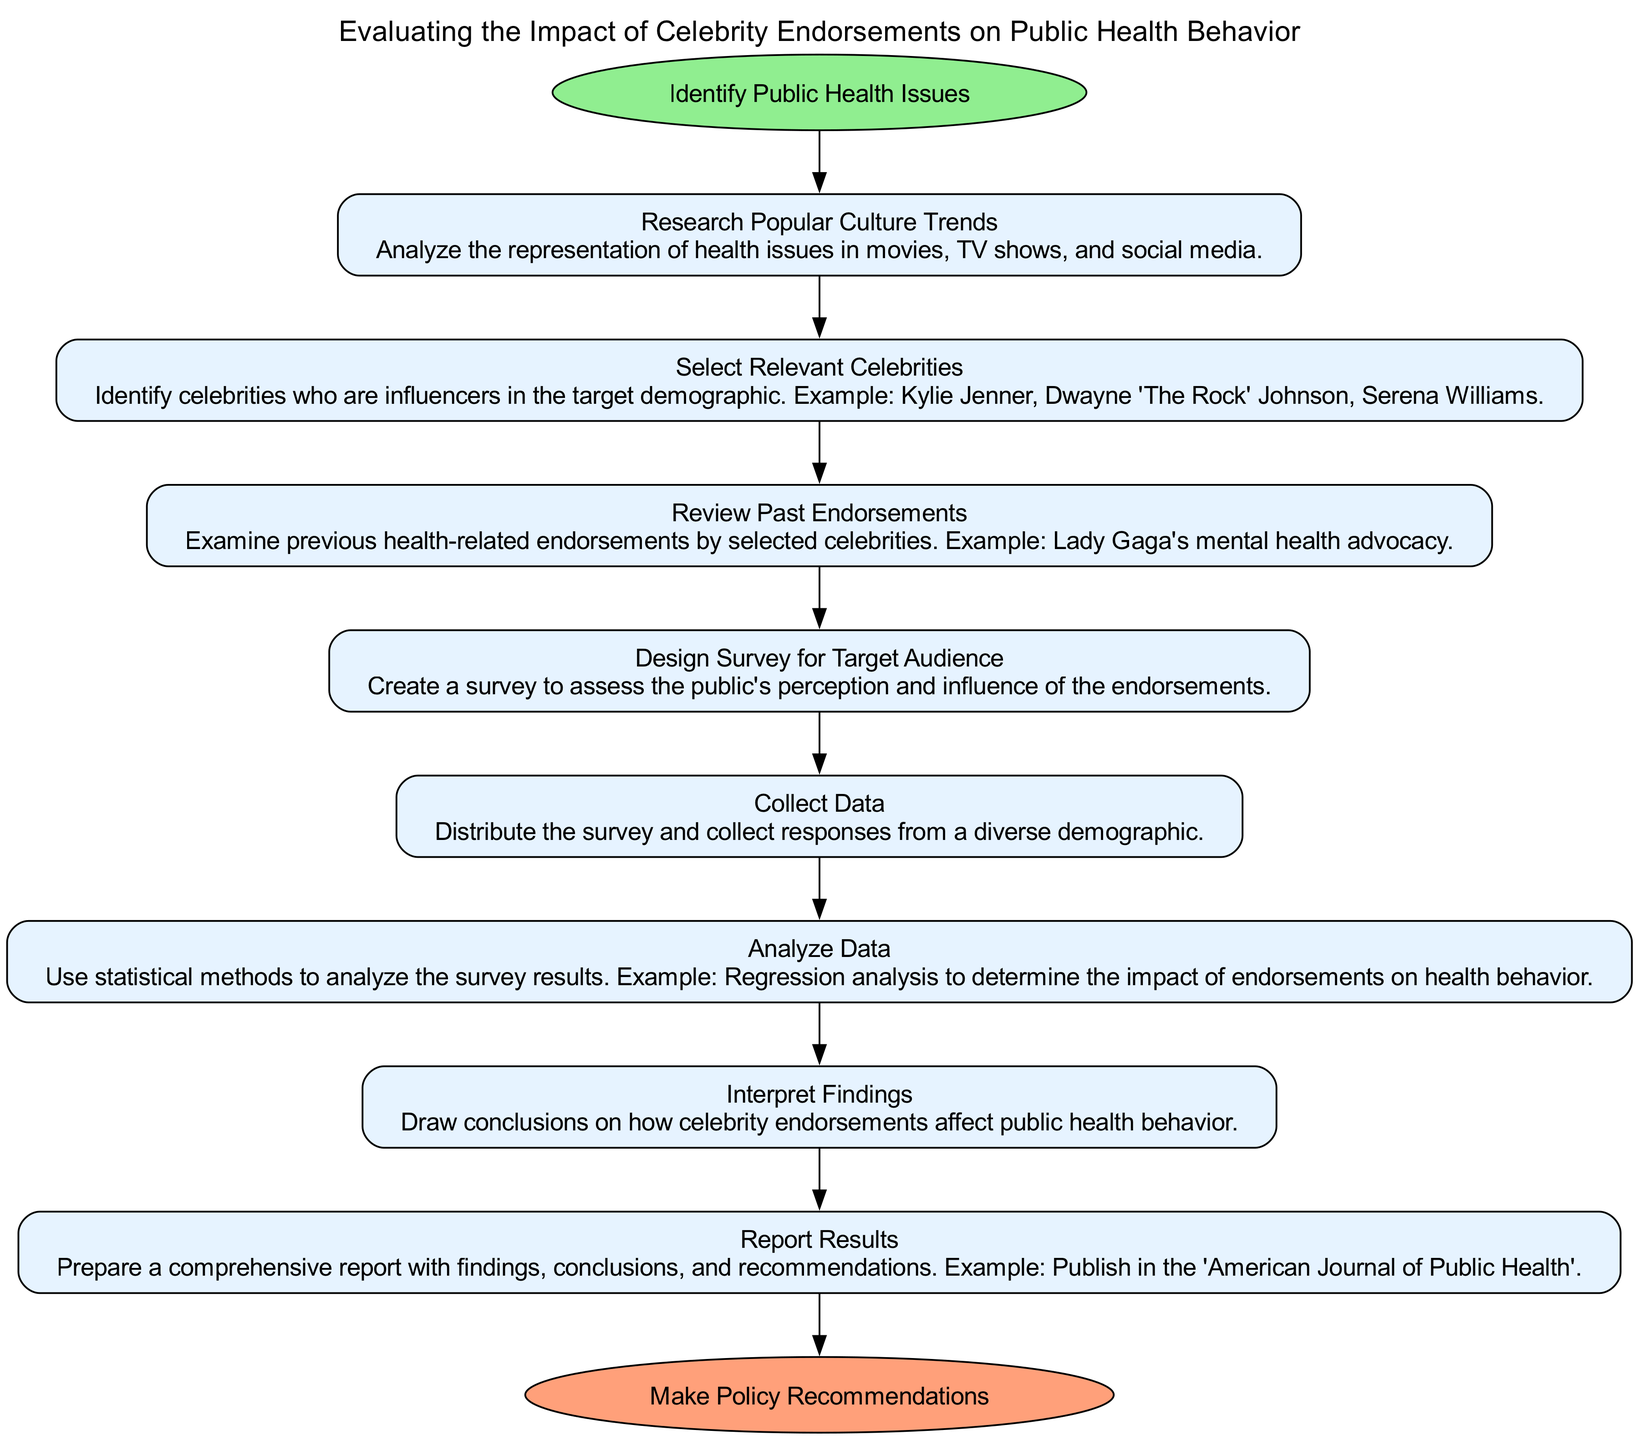What is the starting point of the evaluation process? The starting point is explicitly stated as "Identify Public Health Issues" in the diagram as the first node connected to the starting oval.
Answer: Identify Public Health Issues How many steps are involved in the evaluation process? By counting the number of nodes listed under the steps section in the diagram, there are eight distinct steps depicted.
Answer: Eight What is the last step before making policy recommendations? The last step listed is "Report Results," which directly precedes the endpoint in the flowchart's sequence of actions.
Answer: Report Results Which step follows "Review Past Endorsements"? According to the flow of the diagram, the step that immediately follows "Review Past Endorsements" is "Design Survey for Target Audience." This is connected by a directional edge.
Answer: Design Survey for Target Audience Which celebrities are mentioned as relevant influencers in the endorsement process? The diagram lists celebrities such as "Kylie Jenner," "Dwayne 'The Rock' Johnson," and "Serena Williams" as examples, emphasizing their relevance in the target demographic.
Answer: Kylie Jenner, Dwayne 'The Rock' Johnson, Serena Williams What is the purpose of the "Analyze Data" step? This step entails using statistical methods to examine the survey results, with the goal of understanding the impact of celebrity endorsements on health behavior, as indicated in its description.
Answer: Use statistical methods What connects "Collect Data" and "Analyze Data"? There is a directed flow from "Collect Data" to "Analyze Data" indicated by a connecting edge, showing that analysis occurs after data collection.
Answer: Directed flow Which step includes creating a survey? The "Design Survey for Target Audience" step is where the survey creation is explicitly mentioned as a critical action in the sequence.
Answer: Design Survey for Target Audience 